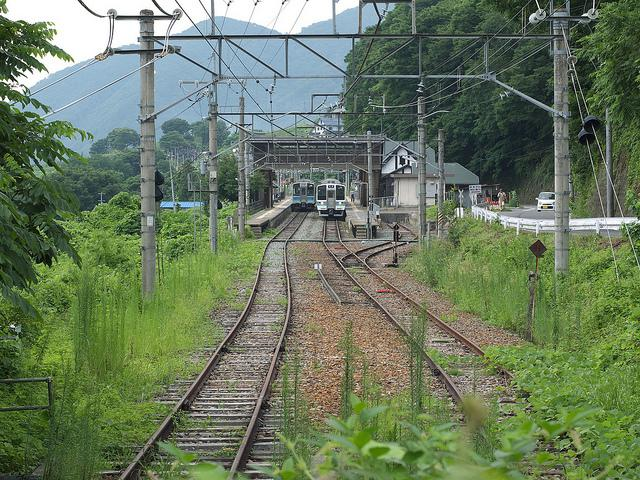There are two trains going down the rail of likely what country?

Choices:
A) korea
B) canada
C) united states
D) japan japan 